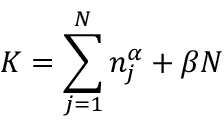Convert formula to latex. <formula><loc_0><loc_0><loc_500><loc_500>K = \sum _ { j = 1 } ^ { N } { n _ { j } ^ { \alpha } } + \beta N</formula> 